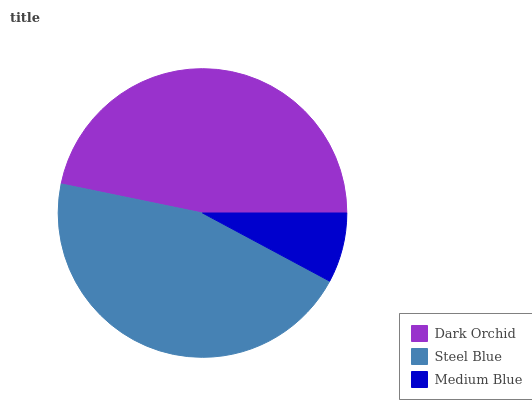Is Medium Blue the minimum?
Answer yes or no. Yes. Is Dark Orchid the maximum?
Answer yes or no. Yes. Is Steel Blue the minimum?
Answer yes or no. No. Is Steel Blue the maximum?
Answer yes or no. No. Is Dark Orchid greater than Steel Blue?
Answer yes or no. Yes. Is Steel Blue less than Dark Orchid?
Answer yes or no. Yes. Is Steel Blue greater than Dark Orchid?
Answer yes or no. No. Is Dark Orchid less than Steel Blue?
Answer yes or no. No. Is Steel Blue the high median?
Answer yes or no. Yes. Is Steel Blue the low median?
Answer yes or no. Yes. Is Medium Blue the high median?
Answer yes or no. No. Is Dark Orchid the low median?
Answer yes or no. No. 